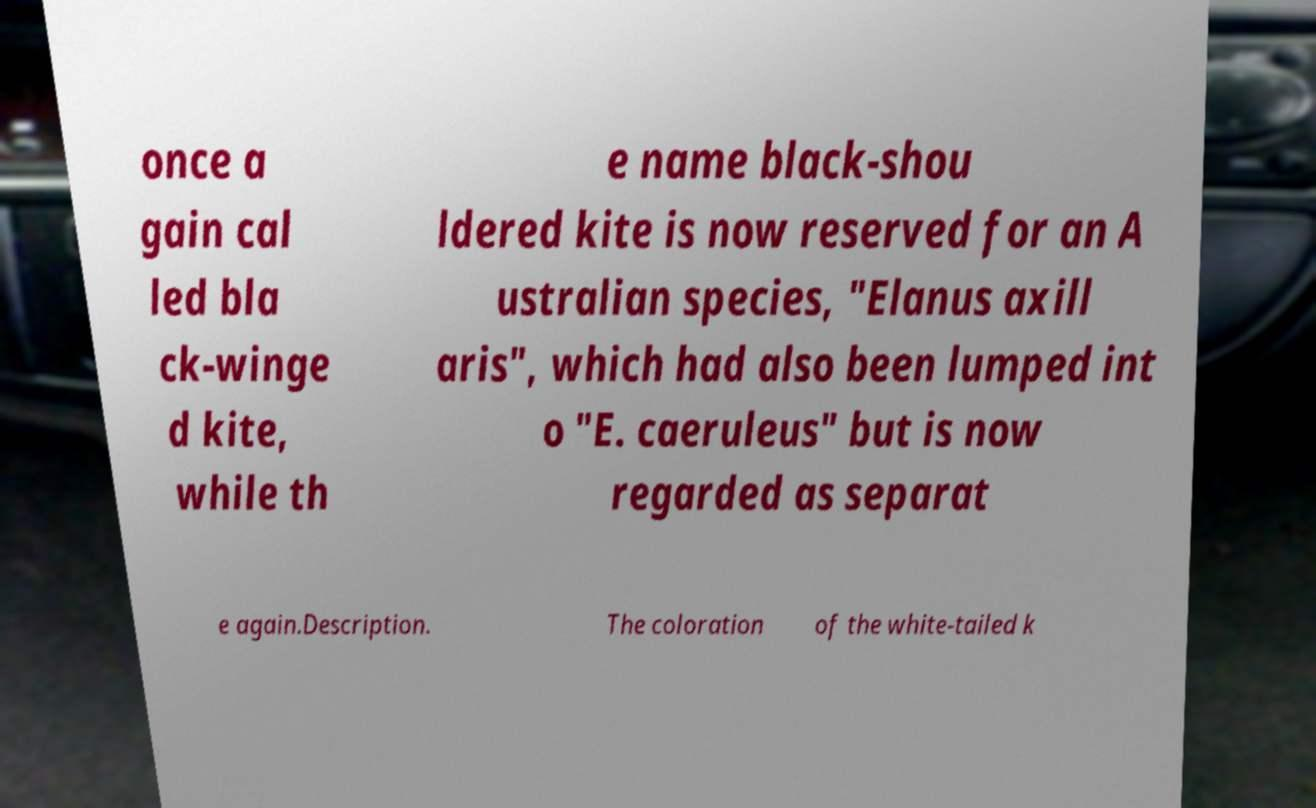Can you accurately transcribe the text from the provided image for me? once a gain cal led bla ck-winge d kite, while th e name black-shou ldered kite is now reserved for an A ustralian species, "Elanus axill aris", which had also been lumped int o "E. caeruleus" but is now regarded as separat e again.Description. The coloration of the white-tailed k 